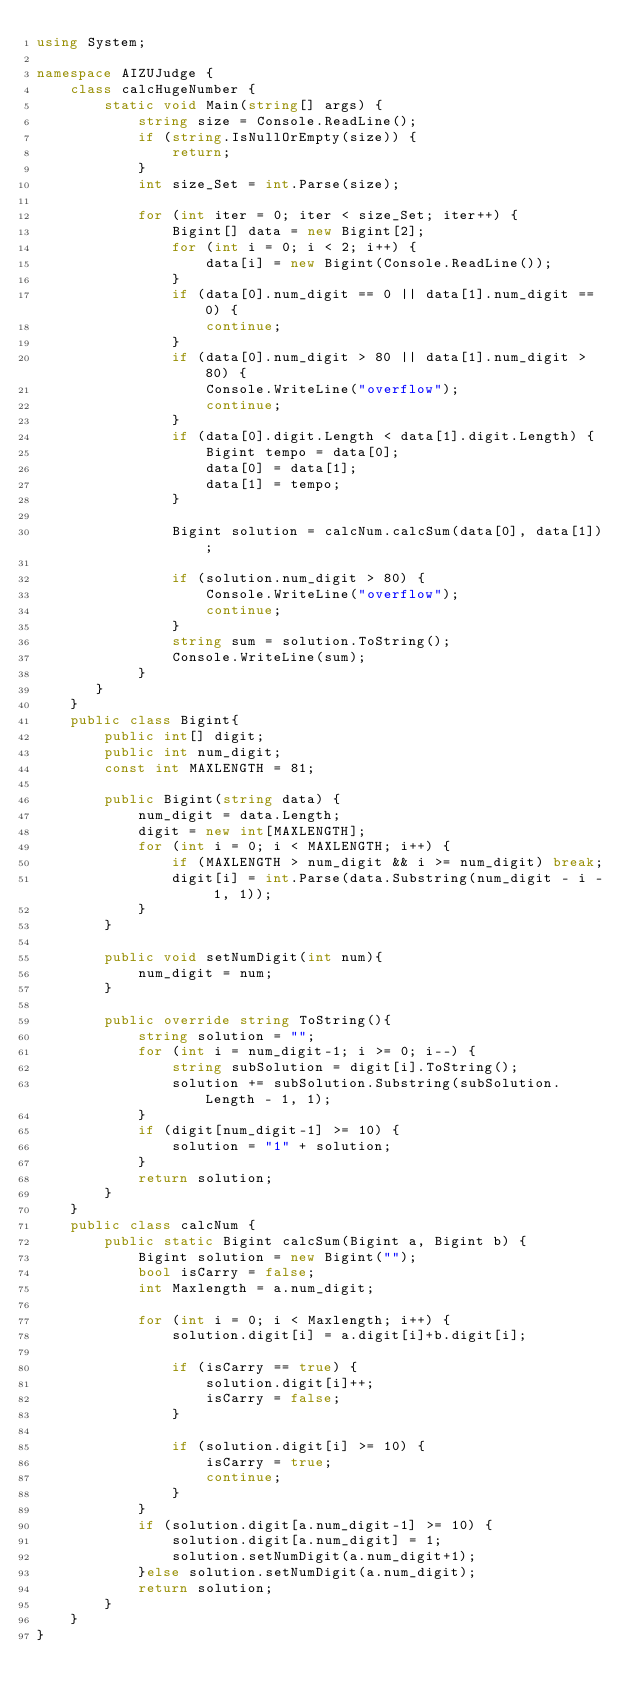Convert code to text. <code><loc_0><loc_0><loc_500><loc_500><_C#_>using System;

namespace AIZUJudge {
    class calcHugeNumber {
        static void Main(string[] args) {
            string size = Console.ReadLine();
            if (string.IsNullOrEmpty(size)) {
                return;
            }
            int size_Set = int.Parse(size);

            for (int iter = 0; iter < size_Set; iter++) {
                Bigint[] data = new Bigint[2];
                for (int i = 0; i < 2; i++) {
                    data[i] = new Bigint(Console.ReadLine());
                }
                if (data[0].num_digit == 0 || data[1].num_digit == 0) {
                    continue;
                }
                if (data[0].num_digit > 80 || data[1].num_digit > 80) {
                    Console.WriteLine("overflow");
                    continue;
                }
                if (data[0].digit.Length < data[1].digit.Length) {
                    Bigint tempo = data[0];
                    data[0] = data[1];
                    data[1] = tempo;
                }

                Bigint solution = calcNum.calcSum(data[0], data[1]);

                if (solution.num_digit > 80) {
                    Console.WriteLine("overflow");
                    continue;
                }
                string sum = solution.ToString();
                Console.WriteLine(sum);
            }
       }
    }
    public class Bigint{
        public int[] digit;
        public int num_digit;
        const int MAXLENGTH = 81;

        public Bigint(string data) {
            num_digit = data.Length;
            digit = new int[MAXLENGTH];
            for (int i = 0; i < MAXLENGTH; i++) {
                if (MAXLENGTH > num_digit && i >= num_digit) break;
                digit[i] = int.Parse(data.Substring(num_digit - i - 1, 1));
			}
        }

        public void setNumDigit(int num){
            num_digit = num;
        }

        public override string ToString(){
            string solution = "";
            for (int i = num_digit-1; i >= 0; i--) {
                string subSolution = digit[i].ToString();
                solution += subSolution.Substring(subSolution.Length - 1, 1);
			}
            if (digit[num_digit-1] >= 10) {
                solution = "1" + solution;
            }
            return solution;
        }
    }
    public class calcNum {
        public static Bigint calcSum(Bigint a, Bigint b) {
            Bigint solution = new Bigint("");
            bool isCarry = false;
            int Maxlength = a.num_digit;

            for (int i = 0; i < Maxlength; i++) {
                solution.digit[i] = a.digit[i]+b.digit[i];

                if (isCarry == true) {
                    solution.digit[i]++;
                    isCarry = false;
                }

                if (solution.digit[i] >= 10) {
                    isCarry = true;
                    continue;
                }
            }
            if (solution.digit[a.num_digit-1] >= 10) {
                solution.digit[a.num_digit] = 1;
                solution.setNumDigit(a.num_digit+1);
            }else solution.setNumDigit(a.num_digit);
            return solution;
        }
    }
}</code> 